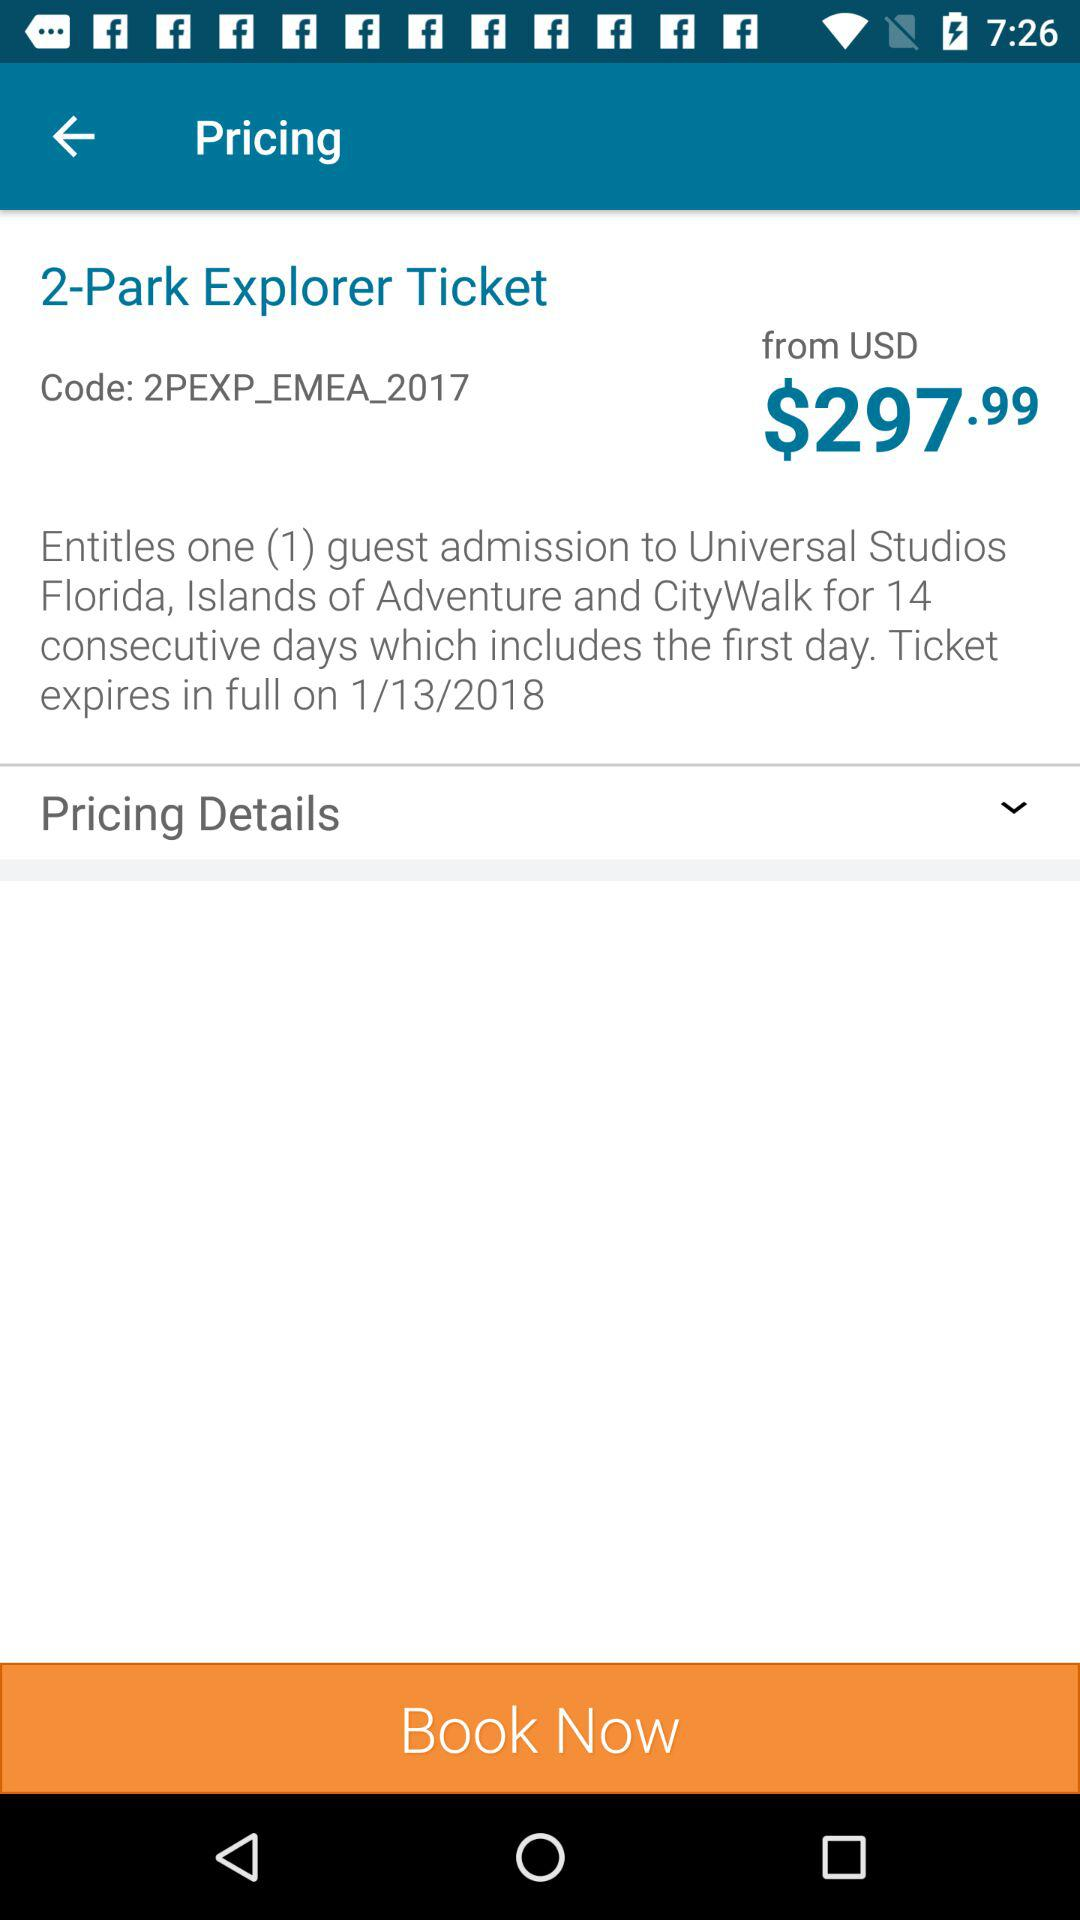For how many consecutive days can the ticket be booked? The ticket can be booked for 14 consecutive days. 